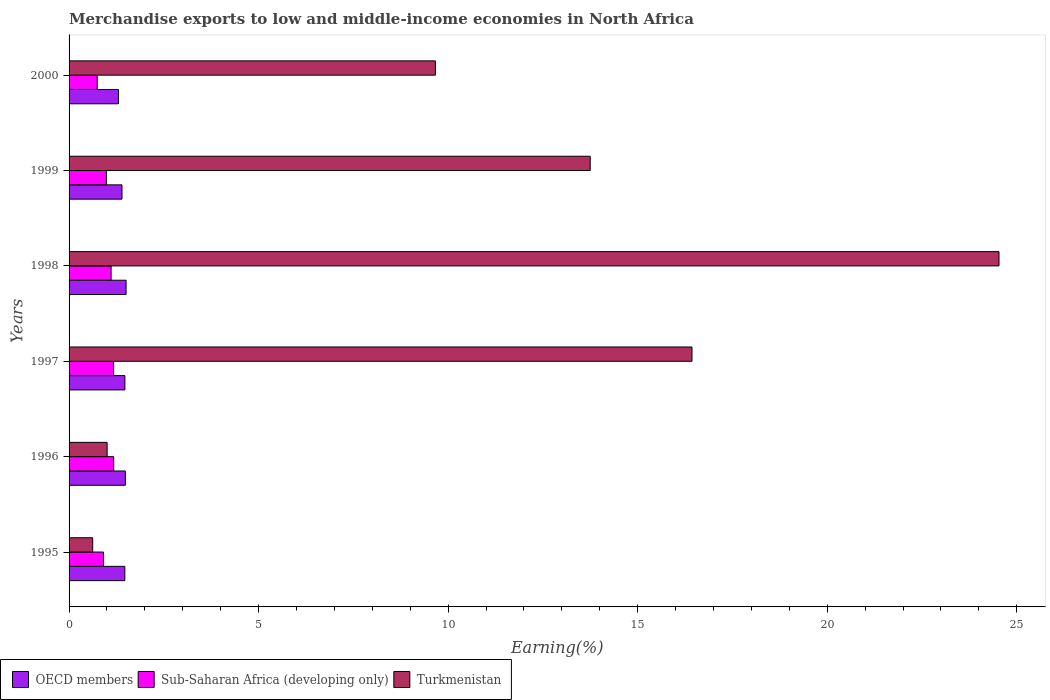How many different coloured bars are there?
Your answer should be very brief. 3. Are the number of bars on each tick of the Y-axis equal?
Your answer should be very brief. Yes. How many bars are there on the 1st tick from the bottom?
Make the answer very short. 3. What is the label of the 5th group of bars from the top?
Your response must be concise. 1996. In how many cases, is the number of bars for a given year not equal to the number of legend labels?
Your answer should be compact. 0. What is the percentage of amount earned from merchandise exports in Turkmenistan in 1995?
Offer a terse response. 0.62. Across all years, what is the maximum percentage of amount earned from merchandise exports in OECD members?
Offer a terse response. 1.5. Across all years, what is the minimum percentage of amount earned from merchandise exports in OECD members?
Ensure brevity in your answer.  1.3. In which year was the percentage of amount earned from merchandise exports in Turkmenistan maximum?
Your answer should be compact. 1998. What is the total percentage of amount earned from merchandise exports in Sub-Saharan Africa (developing only) in the graph?
Provide a short and direct response. 6.1. What is the difference between the percentage of amount earned from merchandise exports in Turkmenistan in 1996 and that in 1999?
Make the answer very short. -12.74. What is the difference between the percentage of amount earned from merchandise exports in OECD members in 1996 and the percentage of amount earned from merchandise exports in Sub-Saharan Africa (developing only) in 2000?
Offer a very short reply. 0.74. What is the average percentage of amount earned from merchandise exports in Sub-Saharan Africa (developing only) per year?
Give a very brief answer. 1.02. In the year 1998, what is the difference between the percentage of amount earned from merchandise exports in OECD members and percentage of amount earned from merchandise exports in Turkmenistan?
Give a very brief answer. -23.03. In how many years, is the percentage of amount earned from merchandise exports in OECD members greater than 23 %?
Give a very brief answer. 0. What is the ratio of the percentage of amount earned from merchandise exports in OECD members in 1996 to that in 1998?
Your answer should be very brief. 0.99. Is the percentage of amount earned from merchandise exports in Turkmenistan in 1995 less than that in 2000?
Your answer should be very brief. Yes. Is the difference between the percentage of amount earned from merchandise exports in OECD members in 1998 and 2000 greater than the difference between the percentage of amount earned from merchandise exports in Turkmenistan in 1998 and 2000?
Your answer should be compact. No. What is the difference between the highest and the second highest percentage of amount earned from merchandise exports in Turkmenistan?
Provide a short and direct response. 8.1. What is the difference between the highest and the lowest percentage of amount earned from merchandise exports in Sub-Saharan Africa (developing only)?
Your response must be concise. 0.44. In how many years, is the percentage of amount earned from merchandise exports in OECD members greater than the average percentage of amount earned from merchandise exports in OECD members taken over all years?
Offer a very short reply. 4. What does the 1st bar from the top in 1996 represents?
Keep it short and to the point. Turkmenistan. What does the 2nd bar from the bottom in 1995 represents?
Provide a short and direct response. Sub-Saharan Africa (developing only). Is it the case that in every year, the sum of the percentage of amount earned from merchandise exports in Turkmenistan and percentage of amount earned from merchandise exports in OECD members is greater than the percentage of amount earned from merchandise exports in Sub-Saharan Africa (developing only)?
Offer a terse response. Yes. How many bars are there?
Make the answer very short. 18. Are the values on the major ticks of X-axis written in scientific E-notation?
Keep it short and to the point. No. Does the graph contain grids?
Give a very brief answer. No. What is the title of the graph?
Make the answer very short. Merchandise exports to low and middle-income economies in North Africa. Does "Macao" appear as one of the legend labels in the graph?
Ensure brevity in your answer.  No. What is the label or title of the X-axis?
Your response must be concise. Earning(%). What is the label or title of the Y-axis?
Offer a terse response. Years. What is the Earning(%) of OECD members in 1995?
Keep it short and to the point. 1.47. What is the Earning(%) of Sub-Saharan Africa (developing only) in 1995?
Ensure brevity in your answer.  0.91. What is the Earning(%) in Turkmenistan in 1995?
Provide a succinct answer. 0.62. What is the Earning(%) in OECD members in 1996?
Offer a very short reply. 1.48. What is the Earning(%) in Sub-Saharan Africa (developing only) in 1996?
Provide a short and direct response. 1.18. What is the Earning(%) of Turkmenistan in 1996?
Provide a short and direct response. 1. What is the Earning(%) in OECD members in 1997?
Give a very brief answer. 1.47. What is the Earning(%) of Sub-Saharan Africa (developing only) in 1997?
Offer a very short reply. 1.18. What is the Earning(%) of Turkmenistan in 1997?
Make the answer very short. 16.43. What is the Earning(%) of OECD members in 1998?
Keep it short and to the point. 1.5. What is the Earning(%) in Sub-Saharan Africa (developing only) in 1998?
Provide a succinct answer. 1.11. What is the Earning(%) of Turkmenistan in 1998?
Provide a short and direct response. 24.53. What is the Earning(%) in OECD members in 1999?
Ensure brevity in your answer.  1.4. What is the Earning(%) of Sub-Saharan Africa (developing only) in 1999?
Ensure brevity in your answer.  0.99. What is the Earning(%) in Turkmenistan in 1999?
Make the answer very short. 13.75. What is the Earning(%) in OECD members in 2000?
Give a very brief answer. 1.3. What is the Earning(%) in Sub-Saharan Africa (developing only) in 2000?
Ensure brevity in your answer.  0.74. What is the Earning(%) in Turkmenistan in 2000?
Provide a short and direct response. 9.66. Across all years, what is the maximum Earning(%) of OECD members?
Your answer should be compact. 1.5. Across all years, what is the maximum Earning(%) in Sub-Saharan Africa (developing only)?
Your response must be concise. 1.18. Across all years, what is the maximum Earning(%) of Turkmenistan?
Your answer should be compact. 24.53. Across all years, what is the minimum Earning(%) of OECD members?
Keep it short and to the point. 1.3. Across all years, what is the minimum Earning(%) of Sub-Saharan Africa (developing only)?
Your answer should be compact. 0.74. Across all years, what is the minimum Earning(%) of Turkmenistan?
Ensure brevity in your answer.  0.62. What is the total Earning(%) in OECD members in the graph?
Your response must be concise. 8.63. What is the total Earning(%) of Sub-Saharan Africa (developing only) in the graph?
Offer a very short reply. 6.1. What is the total Earning(%) of Turkmenistan in the graph?
Your answer should be very brief. 66. What is the difference between the Earning(%) of OECD members in 1995 and that in 1996?
Provide a succinct answer. -0.01. What is the difference between the Earning(%) of Sub-Saharan Africa (developing only) in 1995 and that in 1996?
Provide a short and direct response. -0.27. What is the difference between the Earning(%) of Turkmenistan in 1995 and that in 1996?
Your answer should be very brief. -0.38. What is the difference between the Earning(%) of OECD members in 1995 and that in 1997?
Provide a succinct answer. -0. What is the difference between the Earning(%) of Sub-Saharan Africa (developing only) in 1995 and that in 1997?
Keep it short and to the point. -0.27. What is the difference between the Earning(%) of Turkmenistan in 1995 and that in 1997?
Provide a succinct answer. -15.81. What is the difference between the Earning(%) of OECD members in 1995 and that in 1998?
Provide a short and direct response. -0.03. What is the difference between the Earning(%) in Sub-Saharan Africa (developing only) in 1995 and that in 1998?
Keep it short and to the point. -0.2. What is the difference between the Earning(%) of Turkmenistan in 1995 and that in 1998?
Give a very brief answer. -23.91. What is the difference between the Earning(%) in OECD members in 1995 and that in 1999?
Ensure brevity in your answer.  0.08. What is the difference between the Earning(%) in Sub-Saharan Africa (developing only) in 1995 and that in 1999?
Provide a short and direct response. -0.08. What is the difference between the Earning(%) in Turkmenistan in 1995 and that in 1999?
Offer a very short reply. -13.13. What is the difference between the Earning(%) of OECD members in 1995 and that in 2000?
Provide a short and direct response. 0.17. What is the difference between the Earning(%) in Sub-Saharan Africa (developing only) in 1995 and that in 2000?
Your answer should be very brief. 0.17. What is the difference between the Earning(%) of Turkmenistan in 1995 and that in 2000?
Offer a very short reply. -9.04. What is the difference between the Earning(%) of OECD members in 1996 and that in 1997?
Keep it short and to the point. 0.01. What is the difference between the Earning(%) in Sub-Saharan Africa (developing only) in 1996 and that in 1997?
Provide a succinct answer. 0. What is the difference between the Earning(%) of Turkmenistan in 1996 and that in 1997?
Make the answer very short. -15.43. What is the difference between the Earning(%) in OECD members in 1996 and that in 1998?
Your answer should be very brief. -0.02. What is the difference between the Earning(%) of Sub-Saharan Africa (developing only) in 1996 and that in 1998?
Keep it short and to the point. 0.07. What is the difference between the Earning(%) of Turkmenistan in 1996 and that in 1998?
Keep it short and to the point. -23.53. What is the difference between the Earning(%) in OECD members in 1996 and that in 1999?
Offer a terse response. 0.09. What is the difference between the Earning(%) in Sub-Saharan Africa (developing only) in 1996 and that in 1999?
Your answer should be very brief. 0.19. What is the difference between the Earning(%) in Turkmenistan in 1996 and that in 1999?
Make the answer very short. -12.74. What is the difference between the Earning(%) in OECD members in 1996 and that in 2000?
Your response must be concise. 0.18. What is the difference between the Earning(%) of Sub-Saharan Africa (developing only) in 1996 and that in 2000?
Your response must be concise. 0.44. What is the difference between the Earning(%) in Turkmenistan in 1996 and that in 2000?
Give a very brief answer. -8.66. What is the difference between the Earning(%) of OECD members in 1997 and that in 1998?
Make the answer very short. -0.03. What is the difference between the Earning(%) of Sub-Saharan Africa (developing only) in 1997 and that in 1998?
Your answer should be very brief. 0.07. What is the difference between the Earning(%) in Turkmenistan in 1997 and that in 1998?
Offer a terse response. -8.1. What is the difference between the Earning(%) in OECD members in 1997 and that in 1999?
Your answer should be compact. 0.08. What is the difference between the Earning(%) in Sub-Saharan Africa (developing only) in 1997 and that in 1999?
Offer a terse response. 0.19. What is the difference between the Earning(%) of Turkmenistan in 1997 and that in 1999?
Keep it short and to the point. 2.68. What is the difference between the Earning(%) in OECD members in 1997 and that in 2000?
Ensure brevity in your answer.  0.17. What is the difference between the Earning(%) of Sub-Saharan Africa (developing only) in 1997 and that in 2000?
Offer a very short reply. 0.43. What is the difference between the Earning(%) in Turkmenistan in 1997 and that in 2000?
Keep it short and to the point. 6.77. What is the difference between the Earning(%) in OECD members in 1998 and that in 1999?
Your answer should be very brief. 0.11. What is the difference between the Earning(%) in Sub-Saharan Africa (developing only) in 1998 and that in 1999?
Keep it short and to the point. 0.12. What is the difference between the Earning(%) of Turkmenistan in 1998 and that in 1999?
Provide a short and direct response. 10.78. What is the difference between the Earning(%) in OECD members in 1998 and that in 2000?
Offer a terse response. 0.2. What is the difference between the Earning(%) in Sub-Saharan Africa (developing only) in 1998 and that in 2000?
Your answer should be compact. 0.37. What is the difference between the Earning(%) in Turkmenistan in 1998 and that in 2000?
Your answer should be compact. 14.87. What is the difference between the Earning(%) of OECD members in 1999 and that in 2000?
Provide a short and direct response. 0.09. What is the difference between the Earning(%) in Sub-Saharan Africa (developing only) in 1999 and that in 2000?
Your answer should be very brief. 0.24. What is the difference between the Earning(%) in Turkmenistan in 1999 and that in 2000?
Your answer should be compact. 4.08. What is the difference between the Earning(%) in OECD members in 1995 and the Earning(%) in Sub-Saharan Africa (developing only) in 1996?
Give a very brief answer. 0.29. What is the difference between the Earning(%) of OECD members in 1995 and the Earning(%) of Turkmenistan in 1996?
Offer a terse response. 0.47. What is the difference between the Earning(%) of Sub-Saharan Africa (developing only) in 1995 and the Earning(%) of Turkmenistan in 1996?
Provide a succinct answer. -0.1. What is the difference between the Earning(%) of OECD members in 1995 and the Earning(%) of Sub-Saharan Africa (developing only) in 1997?
Offer a very short reply. 0.3. What is the difference between the Earning(%) of OECD members in 1995 and the Earning(%) of Turkmenistan in 1997?
Your answer should be very brief. -14.96. What is the difference between the Earning(%) of Sub-Saharan Africa (developing only) in 1995 and the Earning(%) of Turkmenistan in 1997?
Provide a succinct answer. -15.53. What is the difference between the Earning(%) in OECD members in 1995 and the Earning(%) in Sub-Saharan Africa (developing only) in 1998?
Your answer should be very brief. 0.36. What is the difference between the Earning(%) of OECD members in 1995 and the Earning(%) of Turkmenistan in 1998?
Provide a succinct answer. -23.06. What is the difference between the Earning(%) in Sub-Saharan Africa (developing only) in 1995 and the Earning(%) in Turkmenistan in 1998?
Make the answer very short. -23.62. What is the difference between the Earning(%) of OECD members in 1995 and the Earning(%) of Sub-Saharan Africa (developing only) in 1999?
Ensure brevity in your answer.  0.49. What is the difference between the Earning(%) in OECD members in 1995 and the Earning(%) in Turkmenistan in 1999?
Your answer should be very brief. -12.28. What is the difference between the Earning(%) in Sub-Saharan Africa (developing only) in 1995 and the Earning(%) in Turkmenistan in 1999?
Provide a short and direct response. -12.84. What is the difference between the Earning(%) of OECD members in 1995 and the Earning(%) of Sub-Saharan Africa (developing only) in 2000?
Provide a short and direct response. 0.73. What is the difference between the Earning(%) of OECD members in 1995 and the Earning(%) of Turkmenistan in 2000?
Ensure brevity in your answer.  -8.19. What is the difference between the Earning(%) of Sub-Saharan Africa (developing only) in 1995 and the Earning(%) of Turkmenistan in 2000?
Offer a terse response. -8.76. What is the difference between the Earning(%) of OECD members in 1996 and the Earning(%) of Sub-Saharan Africa (developing only) in 1997?
Your response must be concise. 0.31. What is the difference between the Earning(%) in OECD members in 1996 and the Earning(%) in Turkmenistan in 1997?
Your response must be concise. -14.95. What is the difference between the Earning(%) in Sub-Saharan Africa (developing only) in 1996 and the Earning(%) in Turkmenistan in 1997?
Keep it short and to the point. -15.26. What is the difference between the Earning(%) in OECD members in 1996 and the Earning(%) in Sub-Saharan Africa (developing only) in 1998?
Ensure brevity in your answer.  0.38. What is the difference between the Earning(%) of OECD members in 1996 and the Earning(%) of Turkmenistan in 1998?
Offer a terse response. -23.05. What is the difference between the Earning(%) in Sub-Saharan Africa (developing only) in 1996 and the Earning(%) in Turkmenistan in 1998?
Your answer should be compact. -23.35. What is the difference between the Earning(%) in OECD members in 1996 and the Earning(%) in Sub-Saharan Africa (developing only) in 1999?
Offer a terse response. 0.5. What is the difference between the Earning(%) of OECD members in 1996 and the Earning(%) of Turkmenistan in 1999?
Your answer should be compact. -12.26. What is the difference between the Earning(%) of Sub-Saharan Africa (developing only) in 1996 and the Earning(%) of Turkmenistan in 1999?
Your response must be concise. -12.57. What is the difference between the Earning(%) in OECD members in 1996 and the Earning(%) in Sub-Saharan Africa (developing only) in 2000?
Give a very brief answer. 0.74. What is the difference between the Earning(%) of OECD members in 1996 and the Earning(%) of Turkmenistan in 2000?
Your response must be concise. -8.18. What is the difference between the Earning(%) in Sub-Saharan Africa (developing only) in 1996 and the Earning(%) in Turkmenistan in 2000?
Keep it short and to the point. -8.49. What is the difference between the Earning(%) in OECD members in 1997 and the Earning(%) in Sub-Saharan Africa (developing only) in 1998?
Ensure brevity in your answer.  0.36. What is the difference between the Earning(%) in OECD members in 1997 and the Earning(%) in Turkmenistan in 1998?
Your answer should be compact. -23.06. What is the difference between the Earning(%) in Sub-Saharan Africa (developing only) in 1997 and the Earning(%) in Turkmenistan in 1998?
Your answer should be compact. -23.36. What is the difference between the Earning(%) in OECD members in 1997 and the Earning(%) in Sub-Saharan Africa (developing only) in 1999?
Offer a terse response. 0.49. What is the difference between the Earning(%) of OECD members in 1997 and the Earning(%) of Turkmenistan in 1999?
Give a very brief answer. -12.28. What is the difference between the Earning(%) of Sub-Saharan Africa (developing only) in 1997 and the Earning(%) of Turkmenistan in 1999?
Your answer should be very brief. -12.57. What is the difference between the Earning(%) in OECD members in 1997 and the Earning(%) in Sub-Saharan Africa (developing only) in 2000?
Your answer should be compact. 0.73. What is the difference between the Earning(%) in OECD members in 1997 and the Earning(%) in Turkmenistan in 2000?
Your answer should be very brief. -8.19. What is the difference between the Earning(%) of Sub-Saharan Africa (developing only) in 1997 and the Earning(%) of Turkmenistan in 2000?
Make the answer very short. -8.49. What is the difference between the Earning(%) of OECD members in 1998 and the Earning(%) of Sub-Saharan Africa (developing only) in 1999?
Ensure brevity in your answer.  0.52. What is the difference between the Earning(%) in OECD members in 1998 and the Earning(%) in Turkmenistan in 1999?
Ensure brevity in your answer.  -12.24. What is the difference between the Earning(%) of Sub-Saharan Africa (developing only) in 1998 and the Earning(%) of Turkmenistan in 1999?
Give a very brief answer. -12.64. What is the difference between the Earning(%) in OECD members in 1998 and the Earning(%) in Sub-Saharan Africa (developing only) in 2000?
Offer a terse response. 0.76. What is the difference between the Earning(%) in OECD members in 1998 and the Earning(%) in Turkmenistan in 2000?
Ensure brevity in your answer.  -8.16. What is the difference between the Earning(%) of Sub-Saharan Africa (developing only) in 1998 and the Earning(%) of Turkmenistan in 2000?
Keep it short and to the point. -8.56. What is the difference between the Earning(%) of OECD members in 1999 and the Earning(%) of Sub-Saharan Africa (developing only) in 2000?
Give a very brief answer. 0.65. What is the difference between the Earning(%) of OECD members in 1999 and the Earning(%) of Turkmenistan in 2000?
Give a very brief answer. -8.27. What is the difference between the Earning(%) of Sub-Saharan Africa (developing only) in 1999 and the Earning(%) of Turkmenistan in 2000?
Your answer should be very brief. -8.68. What is the average Earning(%) in OECD members per year?
Offer a terse response. 1.44. What is the average Earning(%) of Sub-Saharan Africa (developing only) per year?
Provide a short and direct response. 1.02. What is the average Earning(%) of Turkmenistan per year?
Ensure brevity in your answer.  11. In the year 1995, what is the difference between the Earning(%) in OECD members and Earning(%) in Sub-Saharan Africa (developing only)?
Offer a terse response. 0.56. In the year 1995, what is the difference between the Earning(%) in OECD members and Earning(%) in Turkmenistan?
Keep it short and to the point. 0.85. In the year 1995, what is the difference between the Earning(%) of Sub-Saharan Africa (developing only) and Earning(%) of Turkmenistan?
Your answer should be very brief. 0.28. In the year 1996, what is the difference between the Earning(%) of OECD members and Earning(%) of Sub-Saharan Africa (developing only)?
Keep it short and to the point. 0.31. In the year 1996, what is the difference between the Earning(%) of OECD members and Earning(%) of Turkmenistan?
Ensure brevity in your answer.  0.48. In the year 1996, what is the difference between the Earning(%) of Sub-Saharan Africa (developing only) and Earning(%) of Turkmenistan?
Provide a short and direct response. 0.17. In the year 1997, what is the difference between the Earning(%) in OECD members and Earning(%) in Sub-Saharan Africa (developing only)?
Your answer should be compact. 0.3. In the year 1997, what is the difference between the Earning(%) in OECD members and Earning(%) in Turkmenistan?
Your response must be concise. -14.96. In the year 1997, what is the difference between the Earning(%) of Sub-Saharan Africa (developing only) and Earning(%) of Turkmenistan?
Your response must be concise. -15.26. In the year 1998, what is the difference between the Earning(%) of OECD members and Earning(%) of Sub-Saharan Africa (developing only)?
Your answer should be very brief. 0.4. In the year 1998, what is the difference between the Earning(%) in OECD members and Earning(%) in Turkmenistan?
Keep it short and to the point. -23.03. In the year 1998, what is the difference between the Earning(%) in Sub-Saharan Africa (developing only) and Earning(%) in Turkmenistan?
Ensure brevity in your answer.  -23.42. In the year 1999, what is the difference between the Earning(%) of OECD members and Earning(%) of Sub-Saharan Africa (developing only)?
Ensure brevity in your answer.  0.41. In the year 1999, what is the difference between the Earning(%) of OECD members and Earning(%) of Turkmenistan?
Give a very brief answer. -12.35. In the year 1999, what is the difference between the Earning(%) in Sub-Saharan Africa (developing only) and Earning(%) in Turkmenistan?
Offer a terse response. -12.76. In the year 2000, what is the difference between the Earning(%) in OECD members and Earning(%) in Sub-Saharan Africa (developing only)?
Give a very brief answer. 0.56. In the year 2000, what is the difference between the Earning(%) in OECD members and Earning(%) in Turkmenistan?
Ensure brevity in your answer.  -8.36. In the year 2000, what is the difference between the Earning(%) in Sub-Saharan Africa (developing only) and Earning(%) in Turkmenistan?
Ensure brevity in your answer.  -8.92. What is the ratio of the Earning(%) of OECD members in 1995 to that in 1996?
Your response must be concise. 0.99. What is the ratio of the Earning(%) in Sub-Saharan Africa (developing only) in 1995 to that in 1996?
Offer a terse response. 0.77. What is the ratio of the Earning(%) in Turkmenistan in 1995 to that in 1996?
Make the answer very short. 0.62. What is the ratio of the Earning(%) in OECD members in 1995 to that in 1997?
Your answer should be compact. 1. What is the ratio of the Earning(%) of Sub-Saharan Africa (developing only) in 1995 to that in 1997?
Your answer should be very brief. 0.77. What is the ratio of the Earning(%) of Turkmenistan in 1995 to that in 1997?
Provide a succinct answer. 0.04. What is the ratio of the Earning(%) of Sub-Saharan Africa (developing only) in 1995 to that in 1998?
Offer a very short reply. 0.82. What is the ratio of the Earning(%) of Turkmenistan in 1995 to that in 1998?
Provide a succinct answer. 0.03. What is the ratio of the Earning(%) of OECD members in 1995 to that in 1999?
Provide a short and direct response. 1.05. What is the ratio of the Earning(%) in Sub-Saharan Africa (developing only) in 1995 to that in 1999?
Your response must be concise. 0.92. What is the ratio of the Earning(%) of Turkmenistan in 1995 to that in 1999?
Make the answer very short. 0.05. What is the ratio of the Earning(%) of OECD members in 1995 to that in 2000?
Keep it short and to the point. 1.13. What is the ratio of the Earning(%) in Sub-Saharan Africa (developing only) in 1995 to that in 2000?
Keep it short and to the point. 1.22. What is the ratio of the Earning(%) of Turkmenistan in 1995 to that in 2000?
Keep it short and to the point. 0.06. What is the ratio of the Earning(%) in OECD members in 1996 to that in 1997?
Ensure brevity in your answer.  1.01. What is the ratio of the Earning(%) of Sub-Saharan Africa (developing only) in 1996 to that in 1997?
Your response must be concise. 1. What is the ratio of the Earning(%) of Turkmenistan in 1996 to that in 1997?
Provide a short and direct response. 0.06. What is the ratio of the Earning(%) of OECD members in 1996 to that in 1998?
Your response must be concise. 0.99. What is the ratio of the Earning(%) of Sub-Saharan Africa (developing only) in 1996 to that in 1998?
Your answer should be compact. 1.06. What is the ratio of the Earning(%) in Turkmenistan in 1996 to that in 1998?
Ensure brevity in your answer.  0.04. What is the ratio of the Earning(%) of OECD members in 1996 to that in 1999?
Keep it short and to the point. 1.06. What is the ratio of the Earning(%) in Sub-Saharan Africa (developing only) in 1996 to that in 1999?
Your answer should be very brief. 1.2. What is the ratio of the Earning(%) in Turkmenistan in 1996 to that in 1999?
Offer a very short reply. 0.07. What is the ratio of the Earning(%) in OECD members in 1996 to that in 2000?
Provide a short and direct response. 1.14. What is the ratio of the Earning(%) in Sub-Saharan Africa (developing only) in 1996 to that in 2000?
Offer a very short reply. 1.59. What is the ratio of the Earning(%) in Turkmenistan in 1996 to that in 2000?
Make the answer very short. 0.1. What is the ratio of the Earning(%) in OECD members in 1997 to that in 1998?
Provide a succinct answer. 0.98. What is the ratio of the Earning(%) of Sub-Saharan Africa (developing only) in 1997 to that in 1998?
Your answer should be compact. 1.06. What is the ratio of the Earning(%) of Turkmenistan in 1997 to that in 1998?
Your answer should be compact. 0.67. What is the ratio of the Earning(%) of OECD members in 1997 to that in 1999?
Offer a very short reply. 1.05. What is the ratio of the Earning(%) of Sub-Saharan Africa (developing only) in 1997 to that in 1999?
Your response must be concise. 1.19. What is the ratio of the Earning(%) in Turkmenistan in 1997 to that in 1999?
Keep it short and to the point. 1.2. What is the ratio of the Earning(%) in OECD members in 1997 to that in 2000?
Your answer should be very brief. 1.13. What is the ratio of the Earning(%) in Sub-Saharan Africa (developing only) in 1997 to that in 2000?
Keep it short and to the point. 1.58. What is the ratio of the Earning(%) of Turkmenistan in 1997 to that in 2000?
Make the answer very short. 1.7. What is the ratio of the Earning(%) of OECD members in 1998 to that in 1999?
Offer a terse response. 1.08. What is the ratio of the Earning(%) of Sub-Saharan Africa (developing only) in 1998 to that in 1999?
Offer a terse response. 1.13. What is the ratio of the Earning(%) of Turkmenistan in 1998 to that in 1999?
Provide a short and direct response. 1.78. What is the ratio of the Earning(%) of OECD members in 1998 to that in 2000?
Your response must be concise. 1.16. What is the ratio of the Earning(%) of Sub-Saharan Africa (developing only) in 1998 to that in 2000?
Provide a succinct answer. 1.49. What is the ratio of the Earning(%) of Turkmenistan in 1998 to that in 2000?
Give a very brief answer. 2.54. What is the ratio of the Earning(%) of OECD members in 1999 to that in 2000?
Ensure brevity in your answer.  1.07. What is the ratio of the Earning(%) of Sub-Saharan Africa (developing only) in 1999 to that in 2000?
Ensure brevity in your answer.  1.33. What is the ratio of the Earning(%) of Turkmenistan in 1999 to that in 2000?
Your response must be concise. 1.42. What is the difference between the highest and the second highest Earning(%) in OECD members?
Give a very brief answer. 0.02. What is the difference between the highest and the second highest Earning(%) in Sub-Saharan Africa (developing only)?
Offer a terse response. 0. What is the difference between the highest and the second highest Earning(%) in Turkmenistan?
Offer a very short reply. 8.1. What is the difference between the highest and the lowest Earning(%) in OECD members?
Offer a terse response. 0.2. What is the difference between the highest and the lowest Earning(%) of Sub-Saharan Africa (developing only)?
Offer a very short reply. 0.44. What is the difference between the highest and the lowest Earning(%) in Turkmenistan?
Offer a terse response. 23.91. 